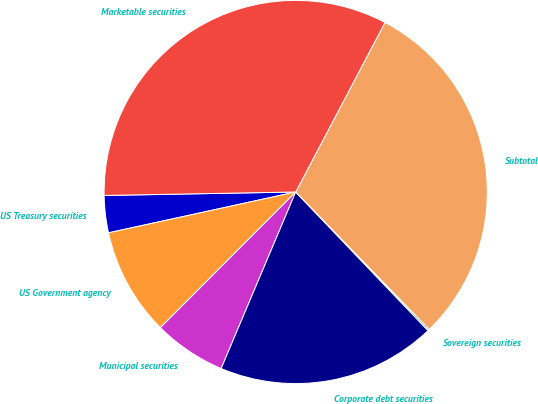<chart> <loc_0><loc_0><loc_500><loc_500><pie_chart><fcel>US Treasury securities<fcel>US Government agency<fcel>Municipal securities<fcel>Corporate debt securities<fcel>Sovereign securities<fcel>Subtotal<fcel>Marketable securities<nl><fcel>3.13%<fcel>9.1%<fcel>6.12%<fcel>18.49%<fcel>0.14%<fcel>30.01%<fcel>33.0%<nl></chart> 